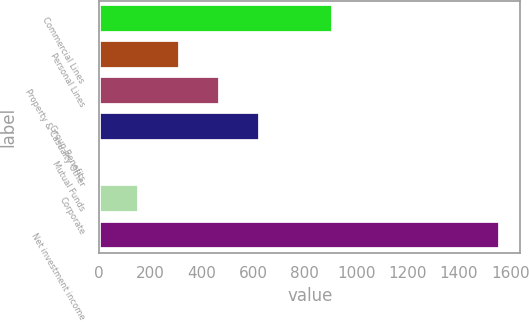Convert chart to OTSL. <chart><loc_0><loc_0><loc_500><loc_500><bar_chart><fcel>Commercial Lines<fcel>Personal Lines<fcel>Property & Casualty Other<fcel>Group Benefits<fcel>Mutual Funds<fcel>Corporate<fcel>Net investment income<nl><fcel>910<fcel>313<fcel>469<fcel>625<fcel>1<fcel>157<fcel>1561<nl></chart> 